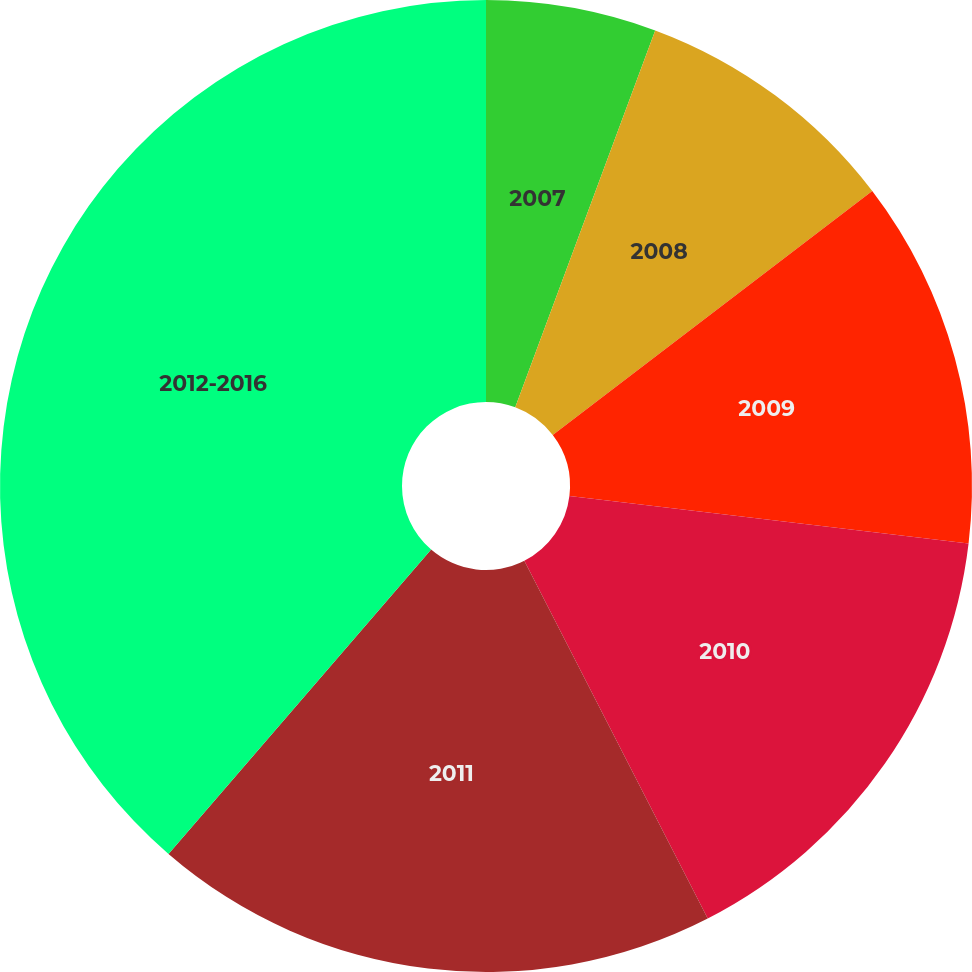Convert chart to OTSL. <chart><loc_0><loc_0><loc_500><loc_500><pie_chart><fcel>2007<fcel>2008<fcel>2009<fcel>2010<fcel>2011<fcel>2012-2016<nl><fcel>5.66%<fcel>8.96%<fcel>12.27%<fcel>15.57%<fcel>18.87%<fcel>38.67%<nl></chart> 